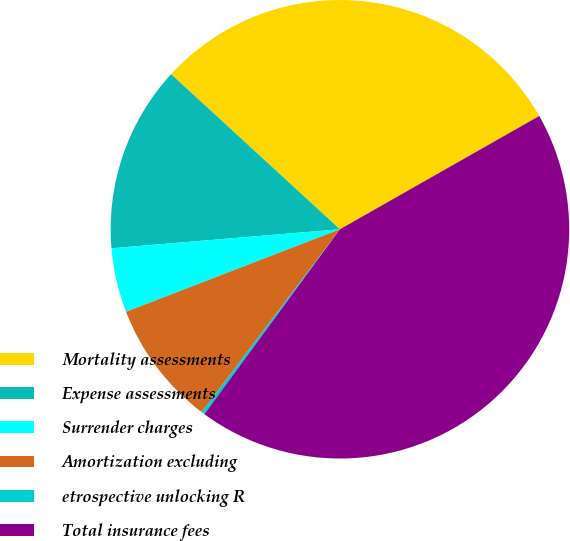Convert chart to OTSL. <chart><loc_0><loc_0><loc_500><loc_500><pie_chart><fcel>Mortality assessments<fcel>Expense assessments<fcel>Surrender charges<fcel>Amortization excluding<fcel>etrospective unlocking R<fcel>Total insurance fees<nl><fcel>29.95%<fcel>13.15%<fcel>4.54%<fcel>8.84%<fcel>0.23%<fcel>43.3%<nl></chart> 